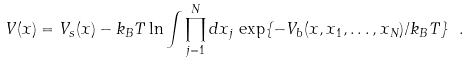Convert formula to latex. <formula><loc_0><loc_0><loc_500><loc_500>V ( x ) = V _ { s } ( x ) - k _ { B } T \ln \int \prod _ { j = 1 } ^ { N } d x _ { j } \, \exp \{ - V _ { b } ( x , x _ { 1 } , \dots , x _ { N } ) / k _ { B } T \} \ .</formula> 